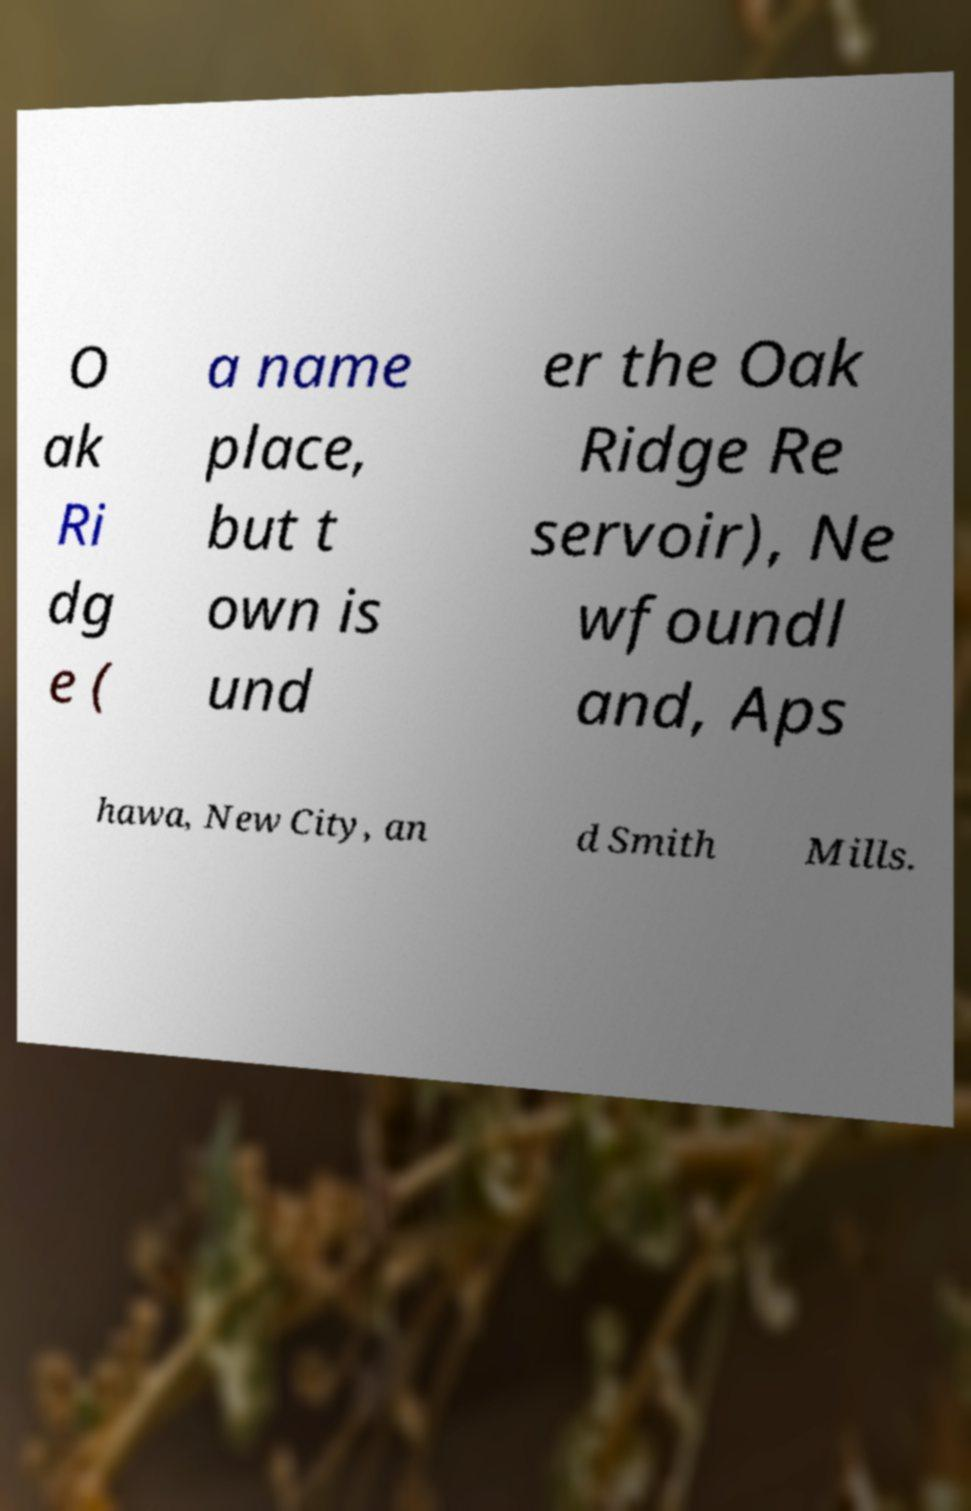Could you extract and type out the text from this image? O ak Ri dg e ( a name place, but t own is und er the Oak Ridge Re servoir), Ne wfoundl and, Aps hawa, New City, an d Smith Mills. 